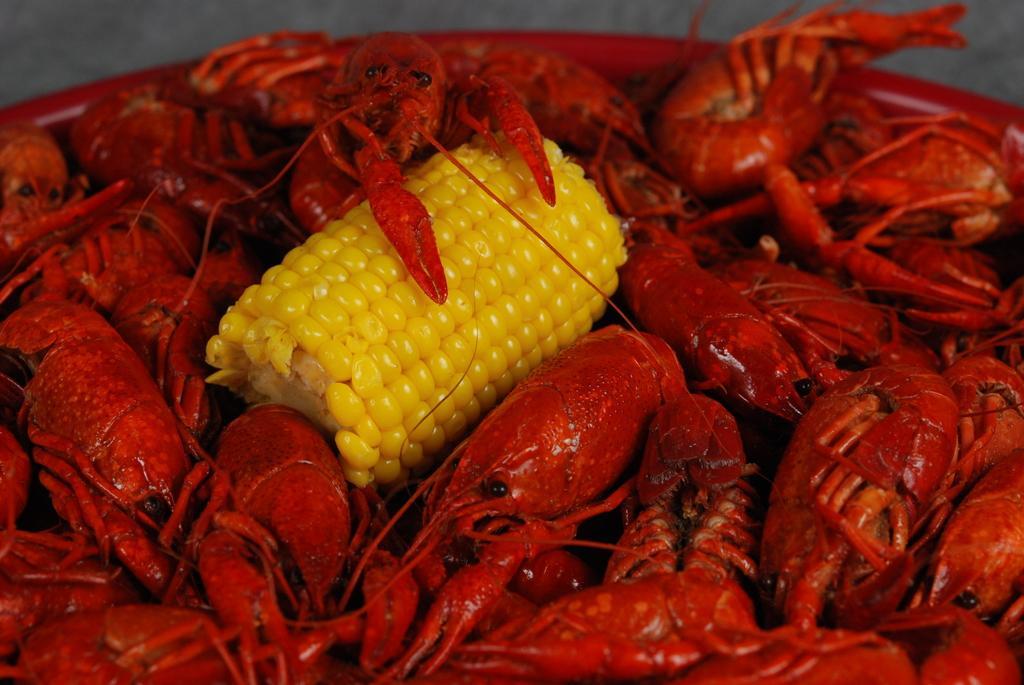Could you give a brief overview of what you see in this image? In the center of the image we can see a corn present in between the red color prawns. 